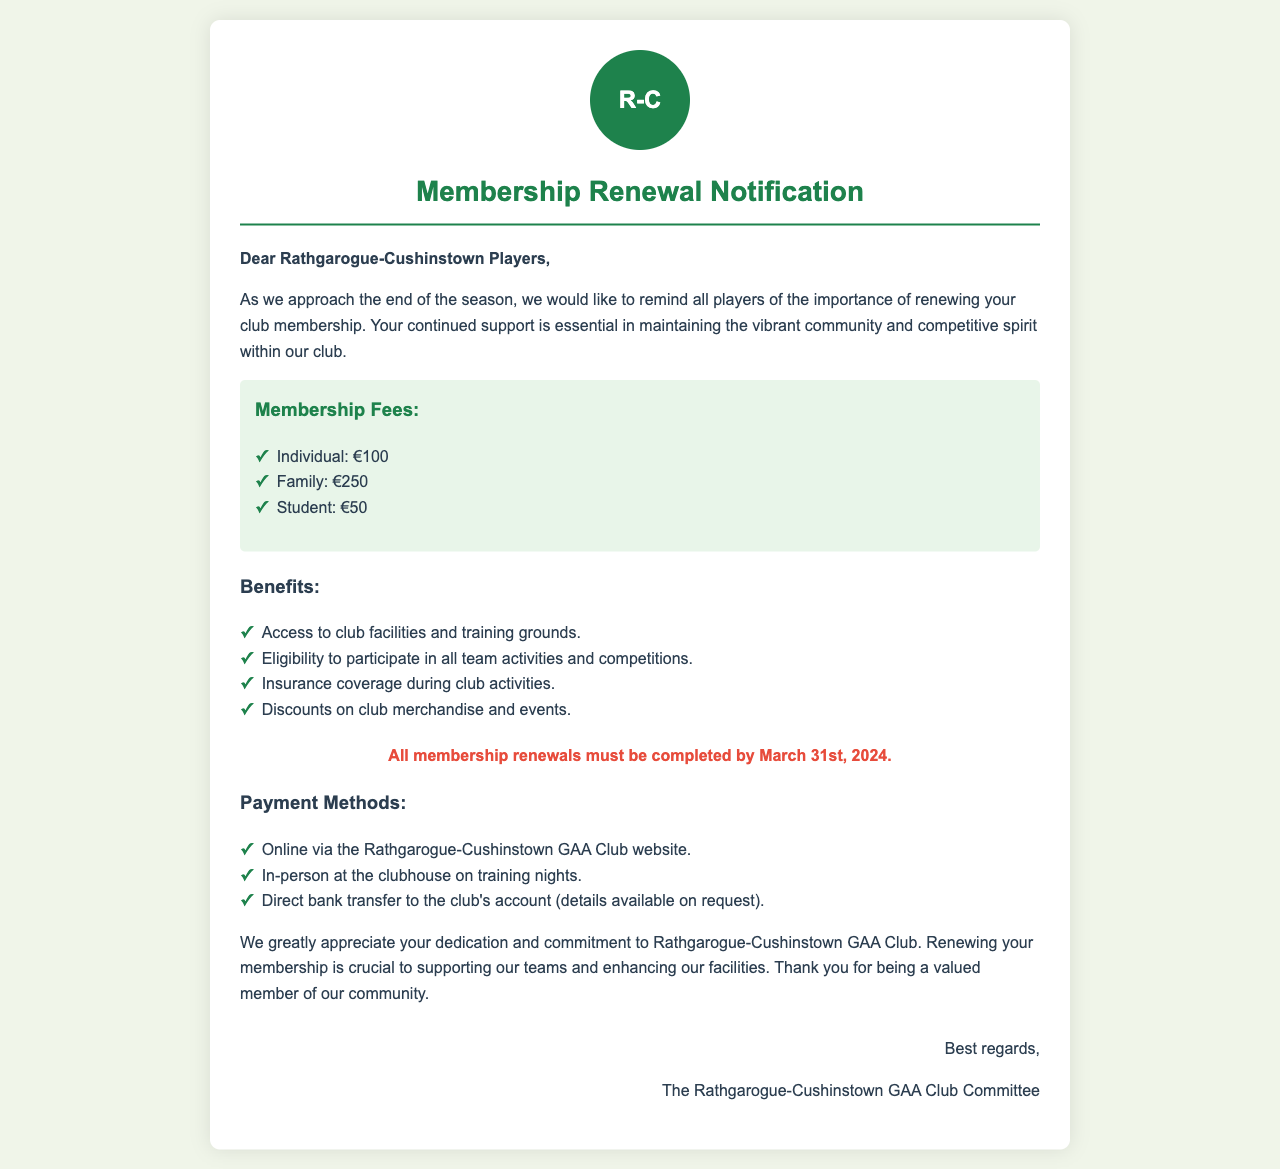What is the individual membership fee? The individual membership fee is listed as €100 in the document.
Answer: €100 What is the family membership fee? The family membership fee is mentioned as €250.
Answer: €250 What is the deadline for membership renewals? The document states that all membership renewals must be completed by March 31st, 2024.
Answer: March 31st, 2024 What percentage of discount on merchandise and events is available to members? The document mentions discounts on club merchandise and events but does not specify a percentage.
Answer: Not specified Which payment method is NOT mentioned in the document? Options like payment through checks or cash are not mentioned; payment methods listed are online, in-person, and direct bank transfer.
Answer: Check or cash What benefits do members receive? Members receive access to club facilities, eligibility for activities, insurance coverage, and discounts.
Answer: Multiple benefits What kind of letter is this document? The document is a Membership Renewal Notification letter.
Answer: Membership Renewal Notification Who signed off the document? The document ends with a signature from The Rathgarogue-Cushinstown GAA Club Committee.
Answer: The Rathgarogue-Cushinstown GAA Club Committee 